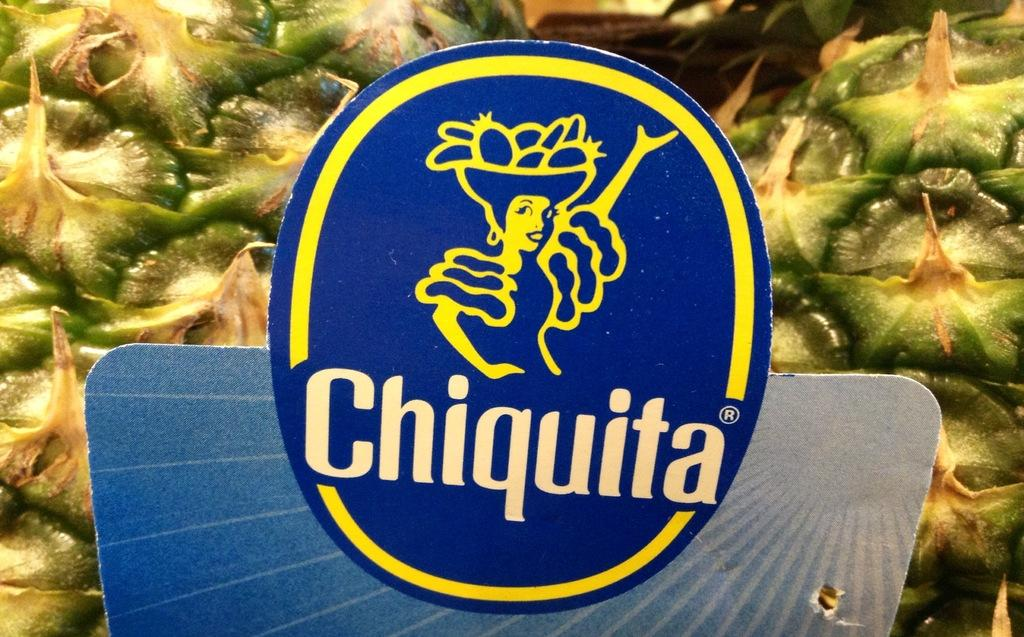What is featured in the image? There is a logo in the image. What does the logo represent? The logo is of a food item. What color is the logo? The logo is in blue color. What type of substance is depicted in the image? There is no substance present in the image; it features a logo of a food item. 